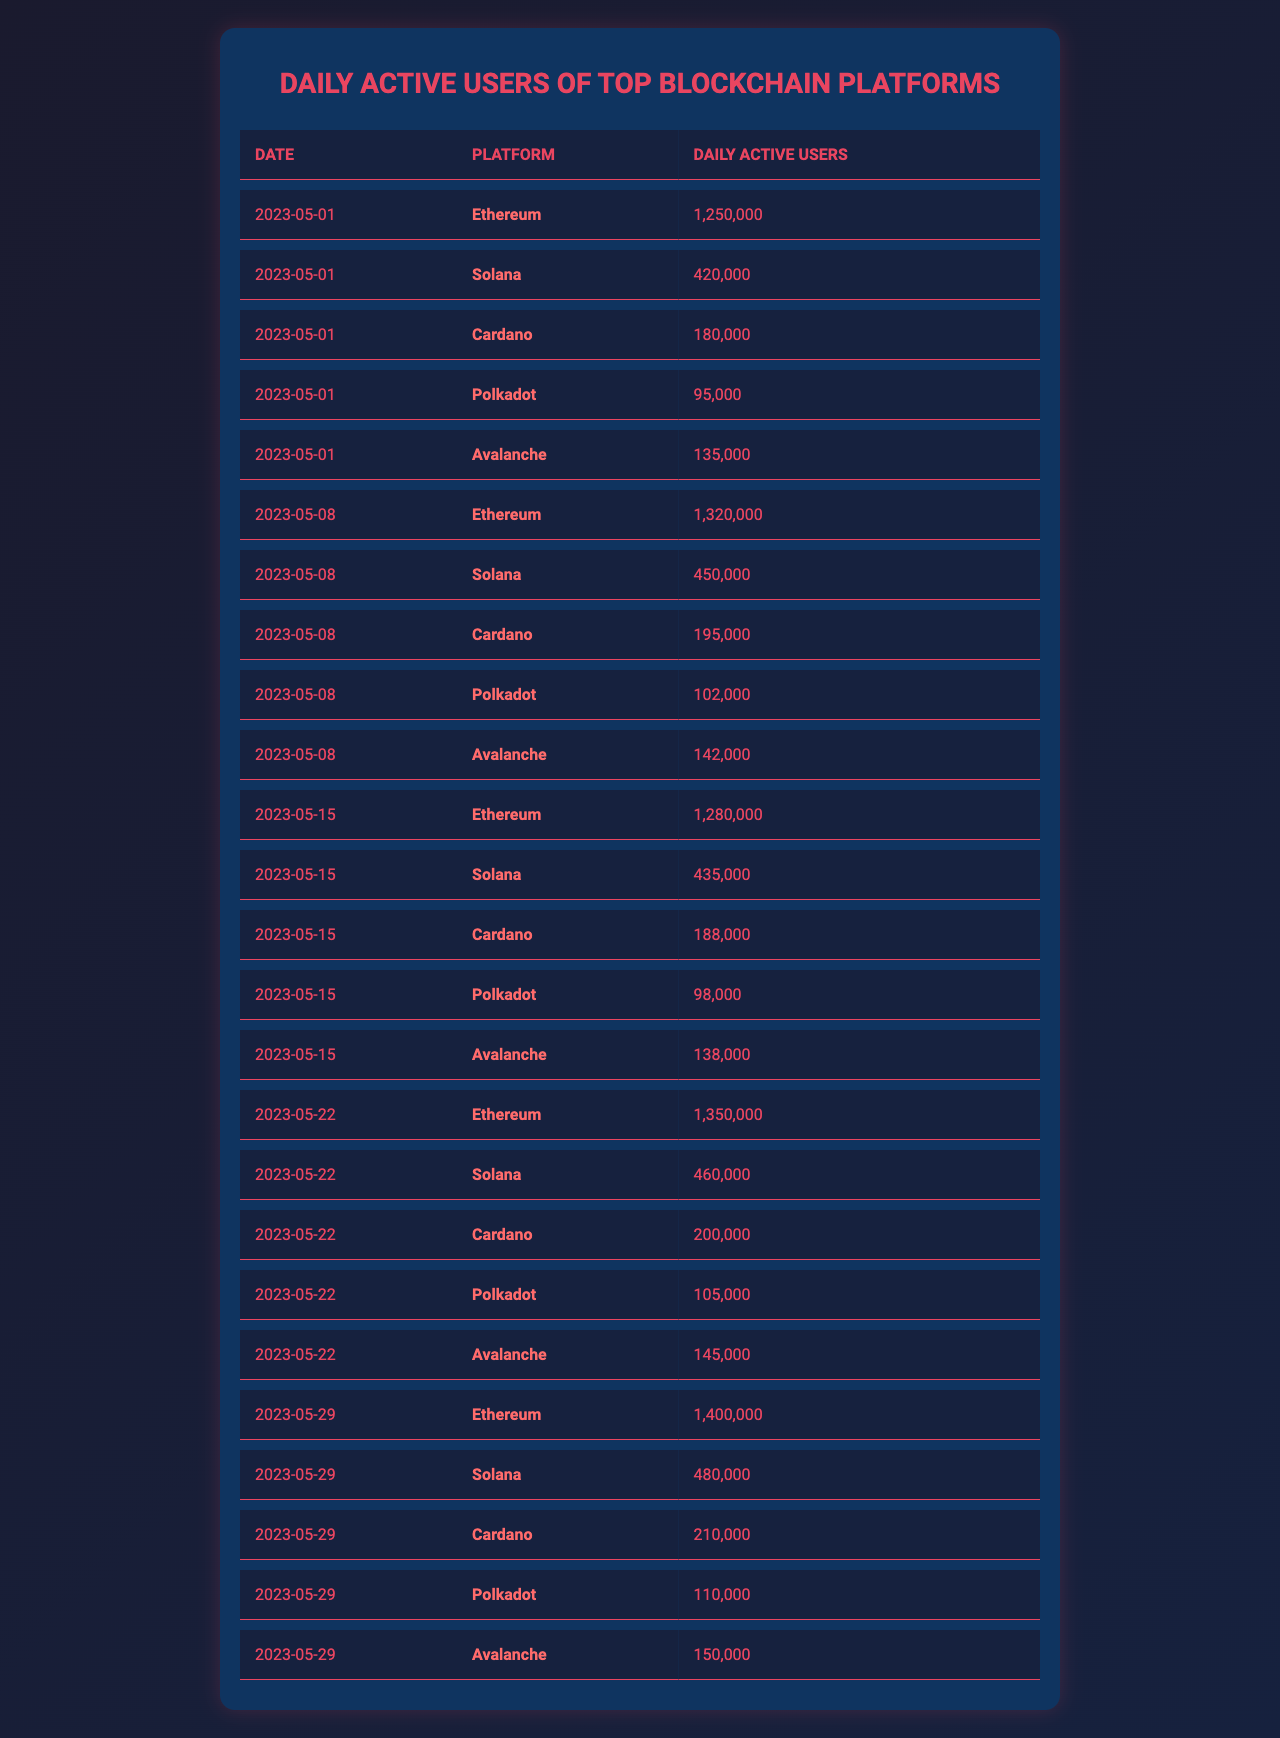What is the highest number of daily active users recorded for Ethereum? The table shows that on May 29, 2023, Ethereum had 1,400,000 daily active users, which is the highest among the recorded data points.
Answer: 1,400,000 On which date did Solana have the least daily active users? By examining the data, Solana had 420,000 daily active users on May 1, 2023, which is the lowest recorded for this platform in the table.
Answer: 420,000 How many daily active users did Cardano have on May 22, 2023? Referring to the entry for Cardano on May 22, 2023, there were 200,000 daily active users recorded.
Answer: 200,000 What is the average number of daily active users for Polkadot over the recorded dates? The daily active users for Polkadot are 95,000 (May 1), 102,000 (May 8), 98,000 (May 15), 105,000 (May 22), and 110,000 (May 29). Adding these values gives 510,000. Dividing by 5 data points results in an average of 102,000 daily active users for Polkadot.
Answer: 102,000 Did Avalanche ever have more daily active users than Cardano? By inspecting the table, Avalanche had 135,000 users on May 1 and continually increased to 150,000 by May 29. In comparison, Cardano's highest was 210,000 on May 29, meaning Avalanche did not surpass Cardano's active users at any point.
Answer: No What is the total increase in daily active users for Solana from May 1 to May 29? Solana had 420,000 active users on May 1 and grew to 480,000 by May 29. The increase can be calculated by subtracting the initial users from the final count: 480,000 - 420,000 = 60,000.
Answer: 60,000 Which blockchain platform showed the highest growth in daily active users between May 1 and May 29? Evaluating the daily active users for each platform between the two dates shows: Ethereum increased by 400,000 (from 1,250,000 to 1,400,000), Solana by 60,000, Cardano by 30,000, Polkadot by 15,000, and Avalanche by 15,000. Ethereum shows the largest growth.
Answer: Ethereum On which date did all platforms show an increase in daily active users compared to the previous week? Checking the data, on May 22, the users for all platforms increased from the figures recorded on May 15.
Answer: May 22 What is the difference in daily active users between the highest and lowest recorded numbers across all platforms on May 29? On May 29, the highest was Ethereum with 1,400,000 users and the lowest was Polkadot with 110,000 users. The difference is computed as 1,400,000 - 110,000 = 1,290,000.
Answer: 1,290,000 How many more daily active users did Avalanche have on May 29 compared to May 1? On May 1, Avalanche had 135,000 users, and by May 29, this increased to 150,000. The difference is 150,000 - 135,000 = 15,000.
Answer: 15,000 Has the daily active user count for Ethereum been consistently increasing every week? Looking at the data for each week shows Ethereum's users were 1,250,000 (May 1), 1,320,000 (May 8), 1,280,000 (May 15), 1,350,000 (May 22), and 1,400,000 (May 29). The second week showed a decrease, indicating it has not been consistent.
Answer: No 